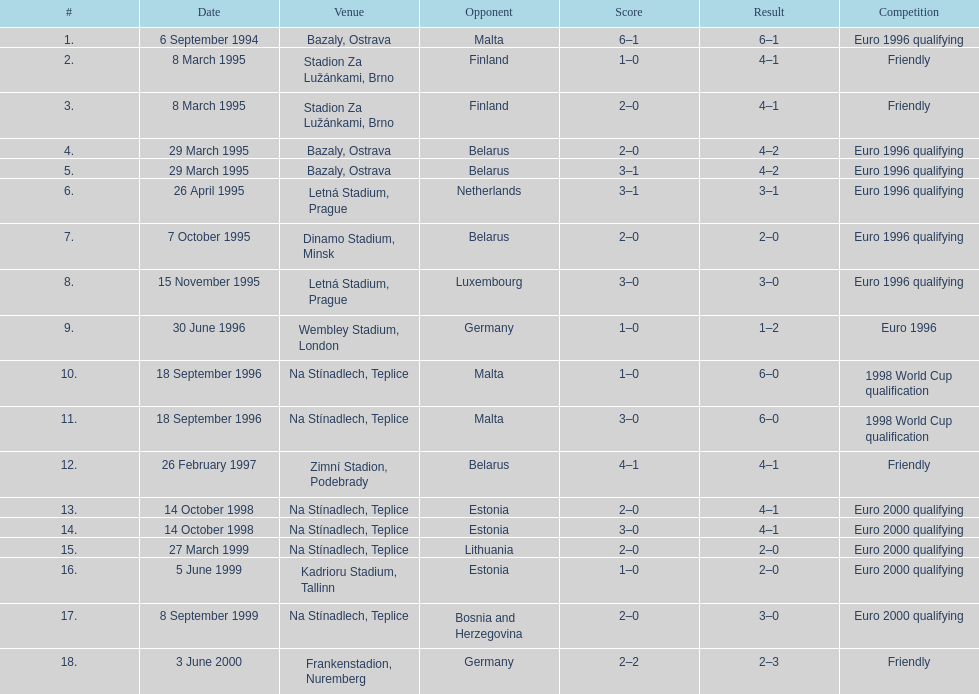How many games were played in total during 1999? 3. 